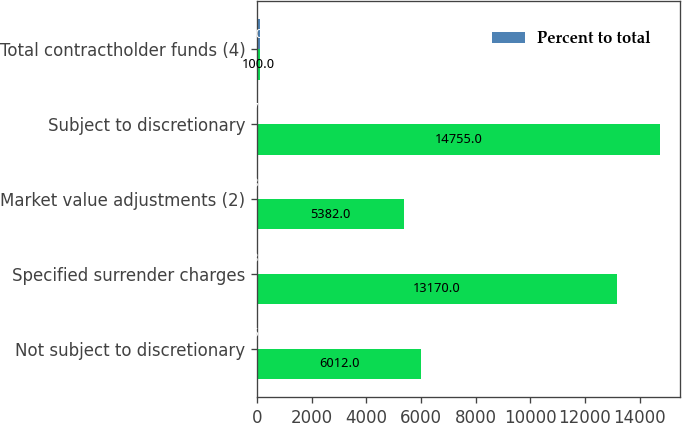<chart> <loc_0><loc_0><loc_500><loc_500><stacked_bar_chart><ecel><fcel>Not subject to discretionary<fcel>Specified surrender charges<fcel>Market value adjustments (2)<fcel>Subject to discretionary<fcel>Total contractholder funds (4)<nl><fcel>nan<fcel>6012<fcel>13170<fcel>5382<fcel>14755<fcel>100<nl><fcel>Percent to total<fcel>15.3<fcel>33.5<fcel>13.7<fcel>37.5<fcel>100<nl></chart> 